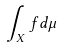<formula> <loc_0><loc_0><loc_500><loc_500>\int _ { X } f d \mu</formula> 